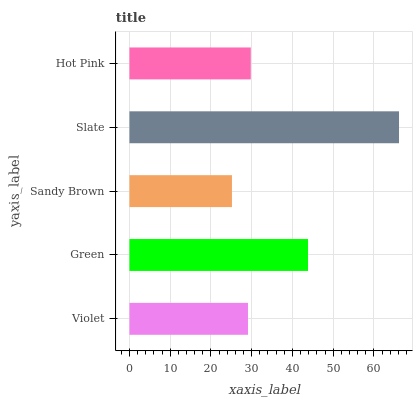Is Sandy Brown the minimum?
Answer yes or no. Yes. Is Slate the maximum?
Answer yes or no. Yes. Is Green the minimum?
Answer yes or no. No. Is Green the maximum?
Answer yes or no. No. Is Green greater than Violet?
Answer yes or no. Yes. Is Violet less than Green?
Answer yes or no. Yes. Is Violet greater than Green?
Answer yes or no. No. Is Green less than Violet?
Answer yes or no. No. Is Hot Pink the high median?
Answer yes or no. Yes. Is Hot Pink the low median?
Answer yes or no. Yes. Is Slate the high median?
Answer yes or no. No. Is Sandy Brown the low median?
Answer yes or no. No. 